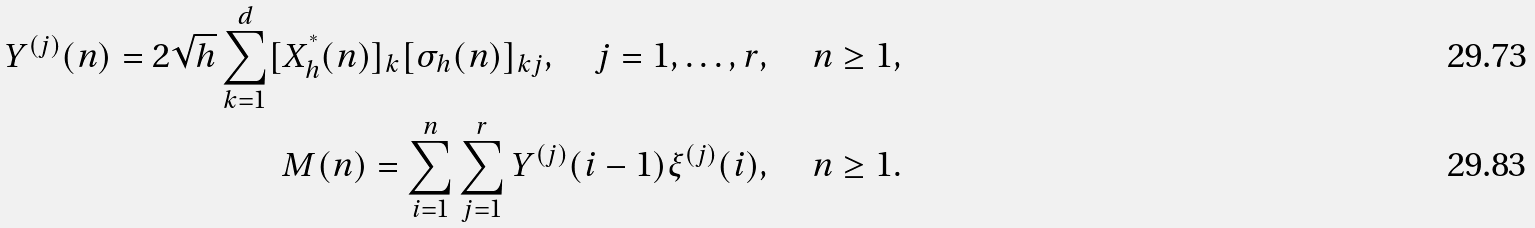<formula> <loc_0><loc_0><loc_500><loc_500>Y ^ { ( j ) } ( n ) = 2 \sqrt { h } \sum _ { k = 1 } ^ { d } [ X _ { h } ^ { ^ { * } } ( n ) ] _ { k } [ \sigma _ { h } ( n ) ] _ { k j } , \quad j = 1 , \dots , r , \quad n \geq 1 , \\ M ( n ) = \sum _ { i = 1 } ^ { n } \sum _ { j = 1 } ^ { r } Y ^ { ( j ) } ( i - 1 ) \xi ^ { ( j ) } ( i ) , \quad n \geq 1 .</formula> 